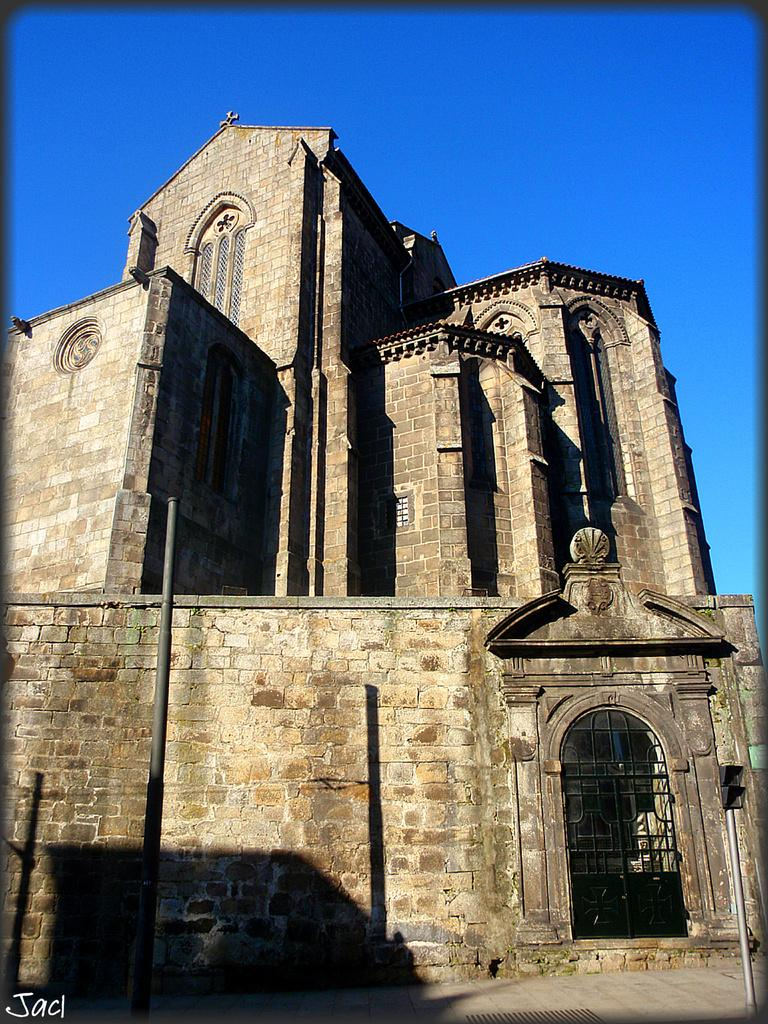What type of structure is in the picture? There is an old building in the picture. What features can be seen on the building? The building has windows and gates. What is visible on the ground in the picture? There is ground visible in the picture. What other objects can be seen in the picture? There are poles and a signal light in the picture. What part of the natural environment is visible in the picture? The sky is visible in the picture. Is there any text present in the image? Yes, there is some text on the bottom left side of the picture. What type of muscle is visible in the picture? There is no muscle visible in the picture; it features an old building, poles, a signal light, and other inanimate objects. 